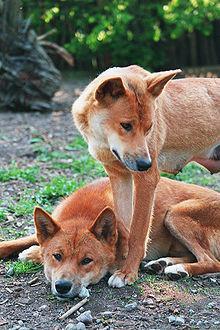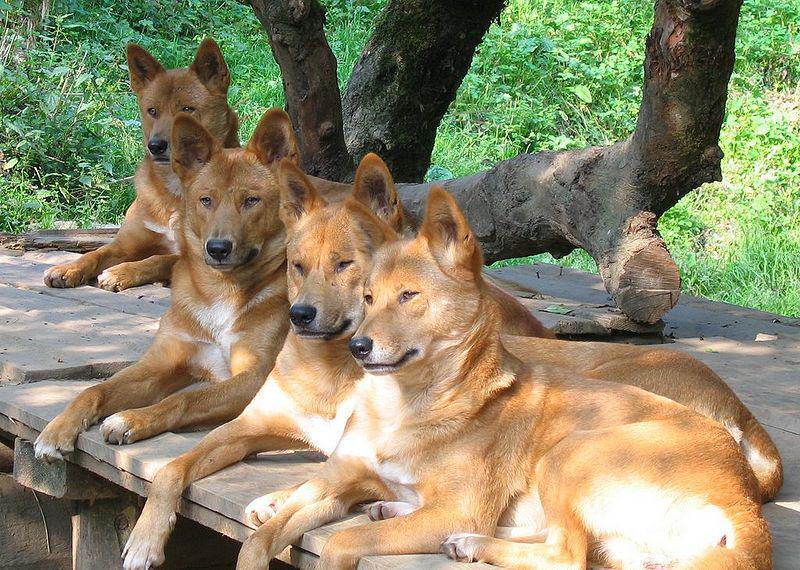The first image is the image on the left, the second image is the image on the right. Examine the images to the left and right. Is the description "There are exactly six dogs in total." accurate? Answer yes or no. Yes. The first image is the image on the left, the second image is the image on the right. Examine the images to the left and right. Is the description "The left image contains two dingos, with one dog's head turned left and lower than the other right-turned head, and the right image contains no dogs that are not reclining." accurate? Answer yes or no. Yes. 